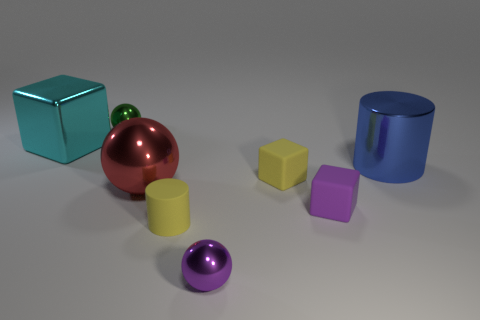Subtract all small balls. How many balls are left? 1 Add 1 yellow matte cylinders. How many objects exist? 9 Subtract all spheres. How many objects are left? 5 Add 4 big metal cylinders. How many big metal cylinders are left? 5 Add 3 large things. How many large things exist? 6 Subtract 0 red blocks. How many objects are left? 8 Subtract all small red matte blocks. Subtract all red balls. How many objects are left? 7 